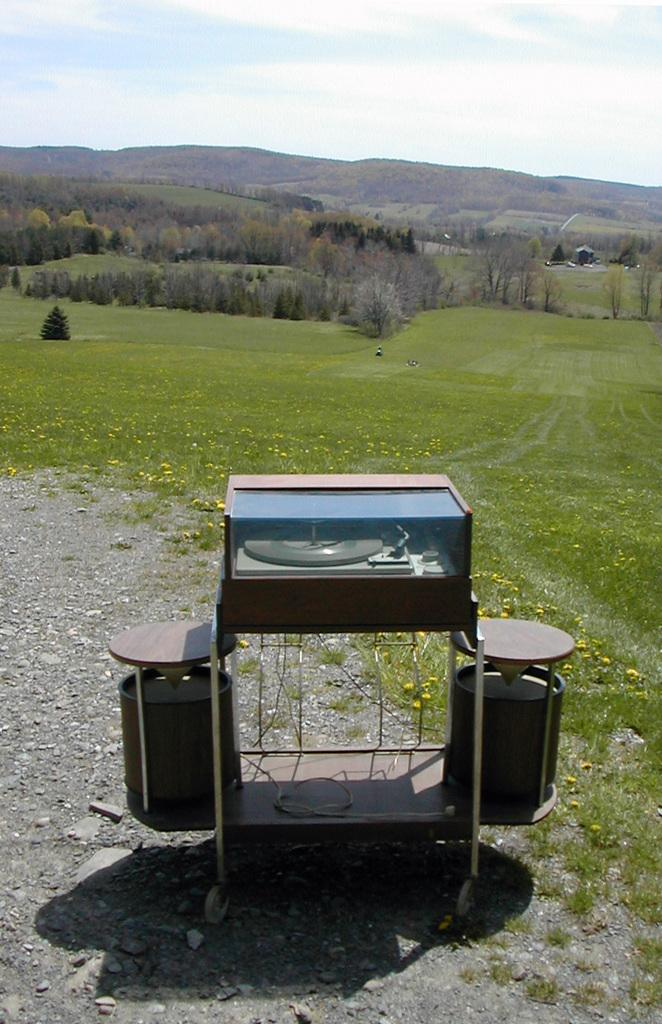What type of terrain is visible in the image? There is an open grass ground in the image. What natural elements can be seen in the image? There are trees in the image. What is visible in the background of the image? The sky is visible in the image. Can you describe the object in the image? There is an object in the image, but its specific details are not mentioned in the facts. What can be observed about the lighting in the image? There is a shadow in the image, which suggests that there is a light source casting the shadow. How many cakes are being played on the drum in the image? There is no drum or cakes present in the image. 